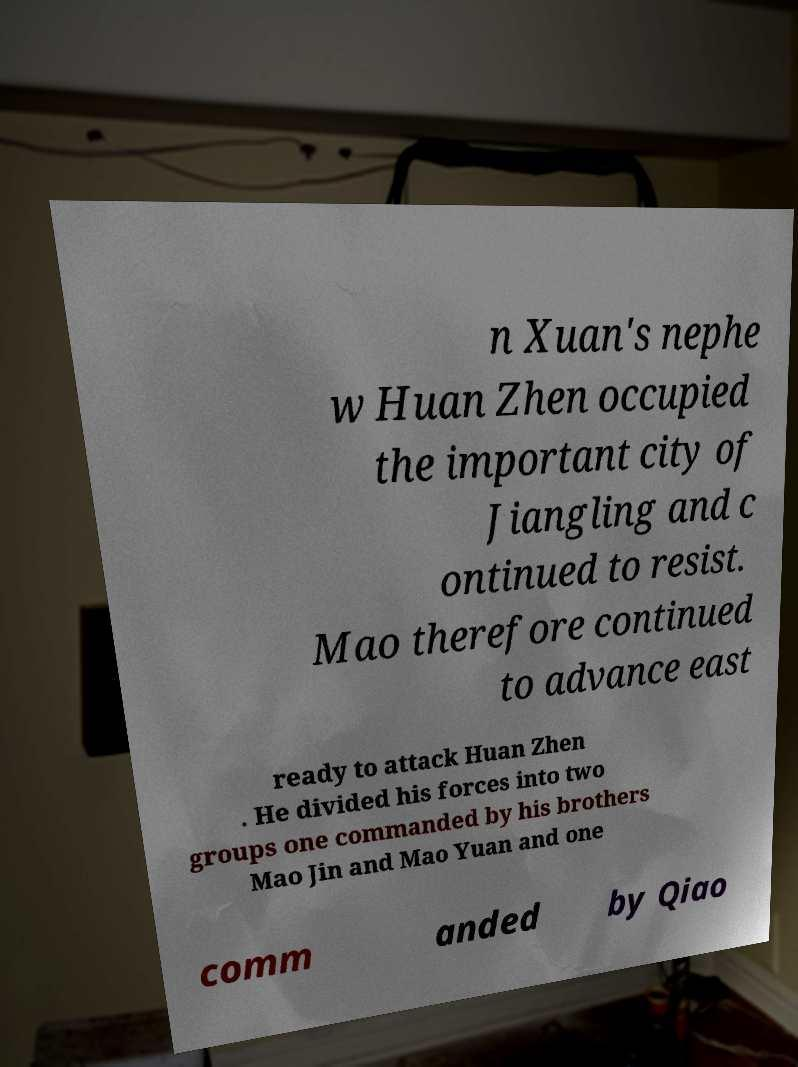Could you extract and type out the text from this image? n Xuan's nephe w Huan Zhen occupied the important city of Jiangling and c ontinued to resist. Mao therefore continued to advance east ready to attack Huan Zhen . He divided his forces into two groups one commanded by his brothers Mao Jin and Mao Yuan and one comm anded by Qiao 